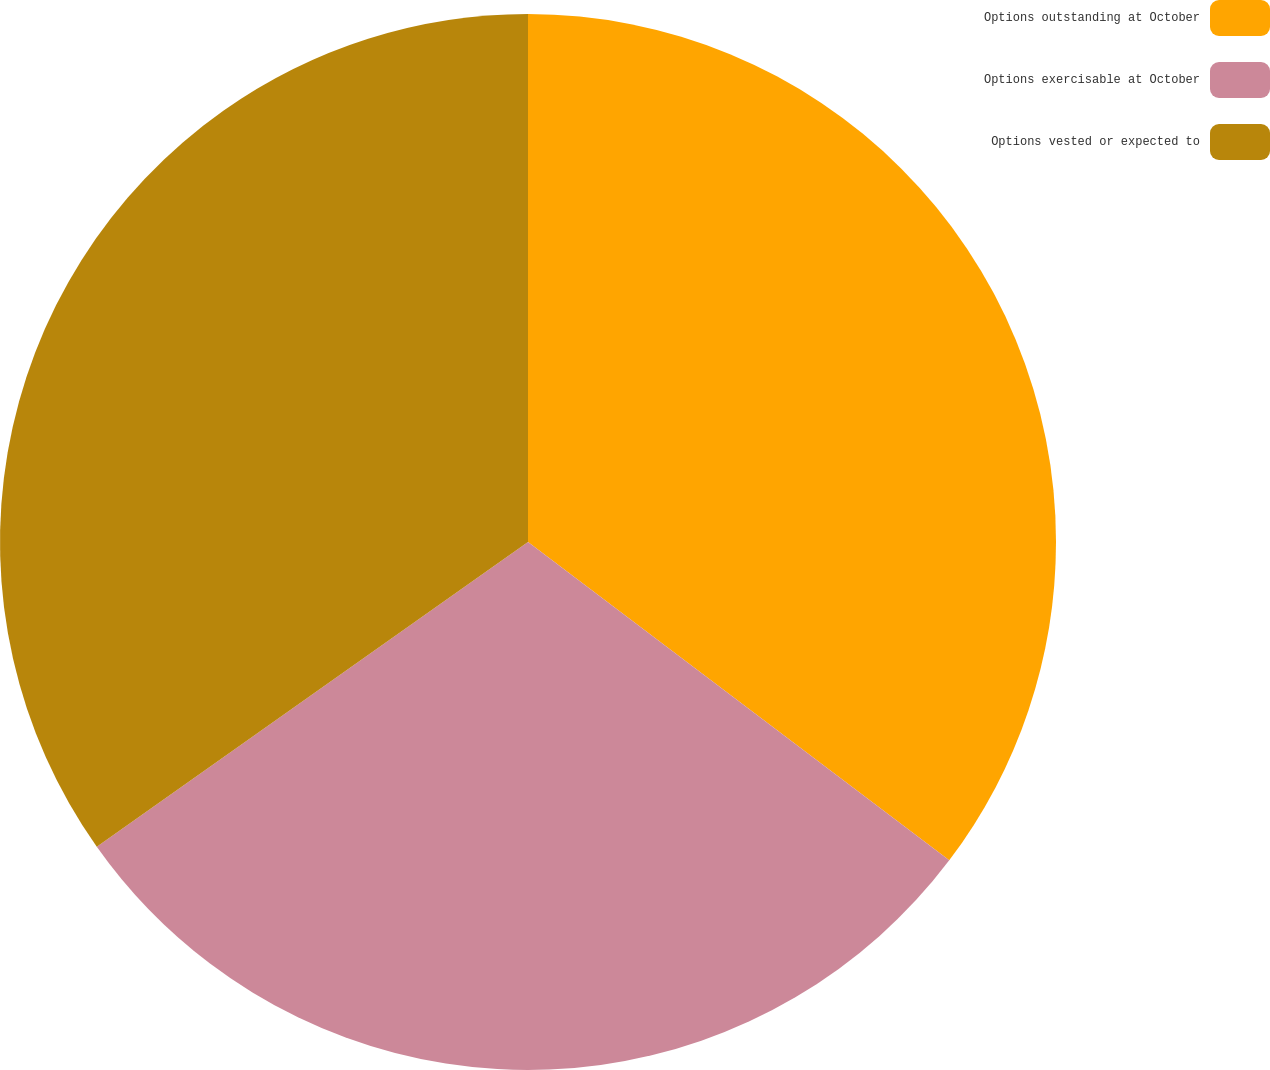Convert chart to OTSL. <chart><loc_0><loc_0><loc_500><loc_500><pie_chart><fcel>Options outstanding at October<fcel>Options exercisable at October<fcel>Options vested or expected to<nl><fcel>35.3%<fcel>29.91%<fcel>34.79%<nl></chart> 